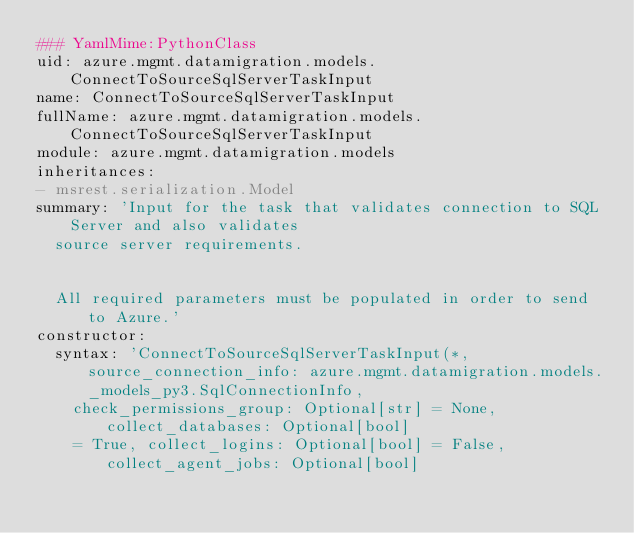<code> <loc_0><loc_0><loc_500><loc_500><_YAML_>### YamlMime:PythonClass
uid: azure.mgmt.datamigration.models.ConnectToSourceSqlServerTaskInput
name: ConnectToSourceSqlServerTaskInput
fullName: azure.mgmt.datamigration.models.ConnectToSourceSqlServerTaskInput
module: azure.mgmt.datamigration.models
inheritances:
- msrest.serialization.Model
summary: 'Input for the task that validates connection to SQL Server and also validates
  source server requirements.


  All required parameters must be populated in order to send to Azure.'
constructor:
  syntax: 'ConnectToSourceSqlServerTaskInput(*, source_connection_info: azure.mgmt.datamigration.models._models_py3.SqlConnectionInfo,
    check_permissions_group: Optional[str] = None, collect_databases: Optional[bool]
    = True, collect_logins: Optional[bool] = False, collect_agent_jobs: Optional[bool]</code> 